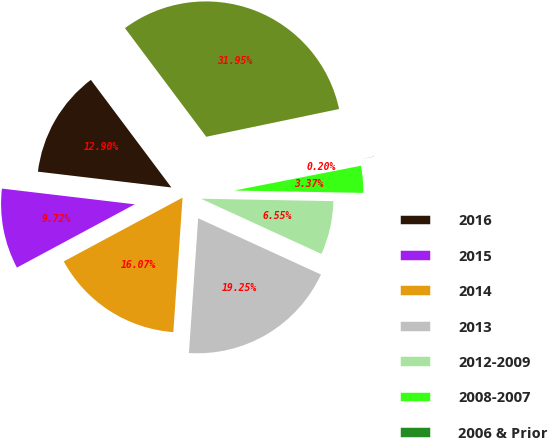Convert chart. <chart><loc_0><loc_0><loc_500><loc_500><pie_chart><fcel>2016<fcel>2015<fcel>2014<fcel>2013<fcel>2012-2009<fcel>2008-2007<fcel>2006 & Prior<fcel>Total commercial<nl><fcel>12.9%<fcel>9.72%<fcel>16.07%<fcel>19.25%<fcel>6.55%<fcel>3.37%<fcel>0.2%<fcel>31.95%<nl></chart> 